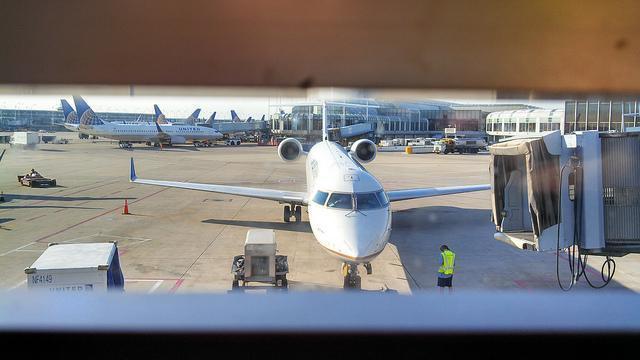What is the large vehicle here?
Select the accurate response from the four choices given to answer the question.
Options: Helicopter, airplane, tank, submarine. Airplane. 